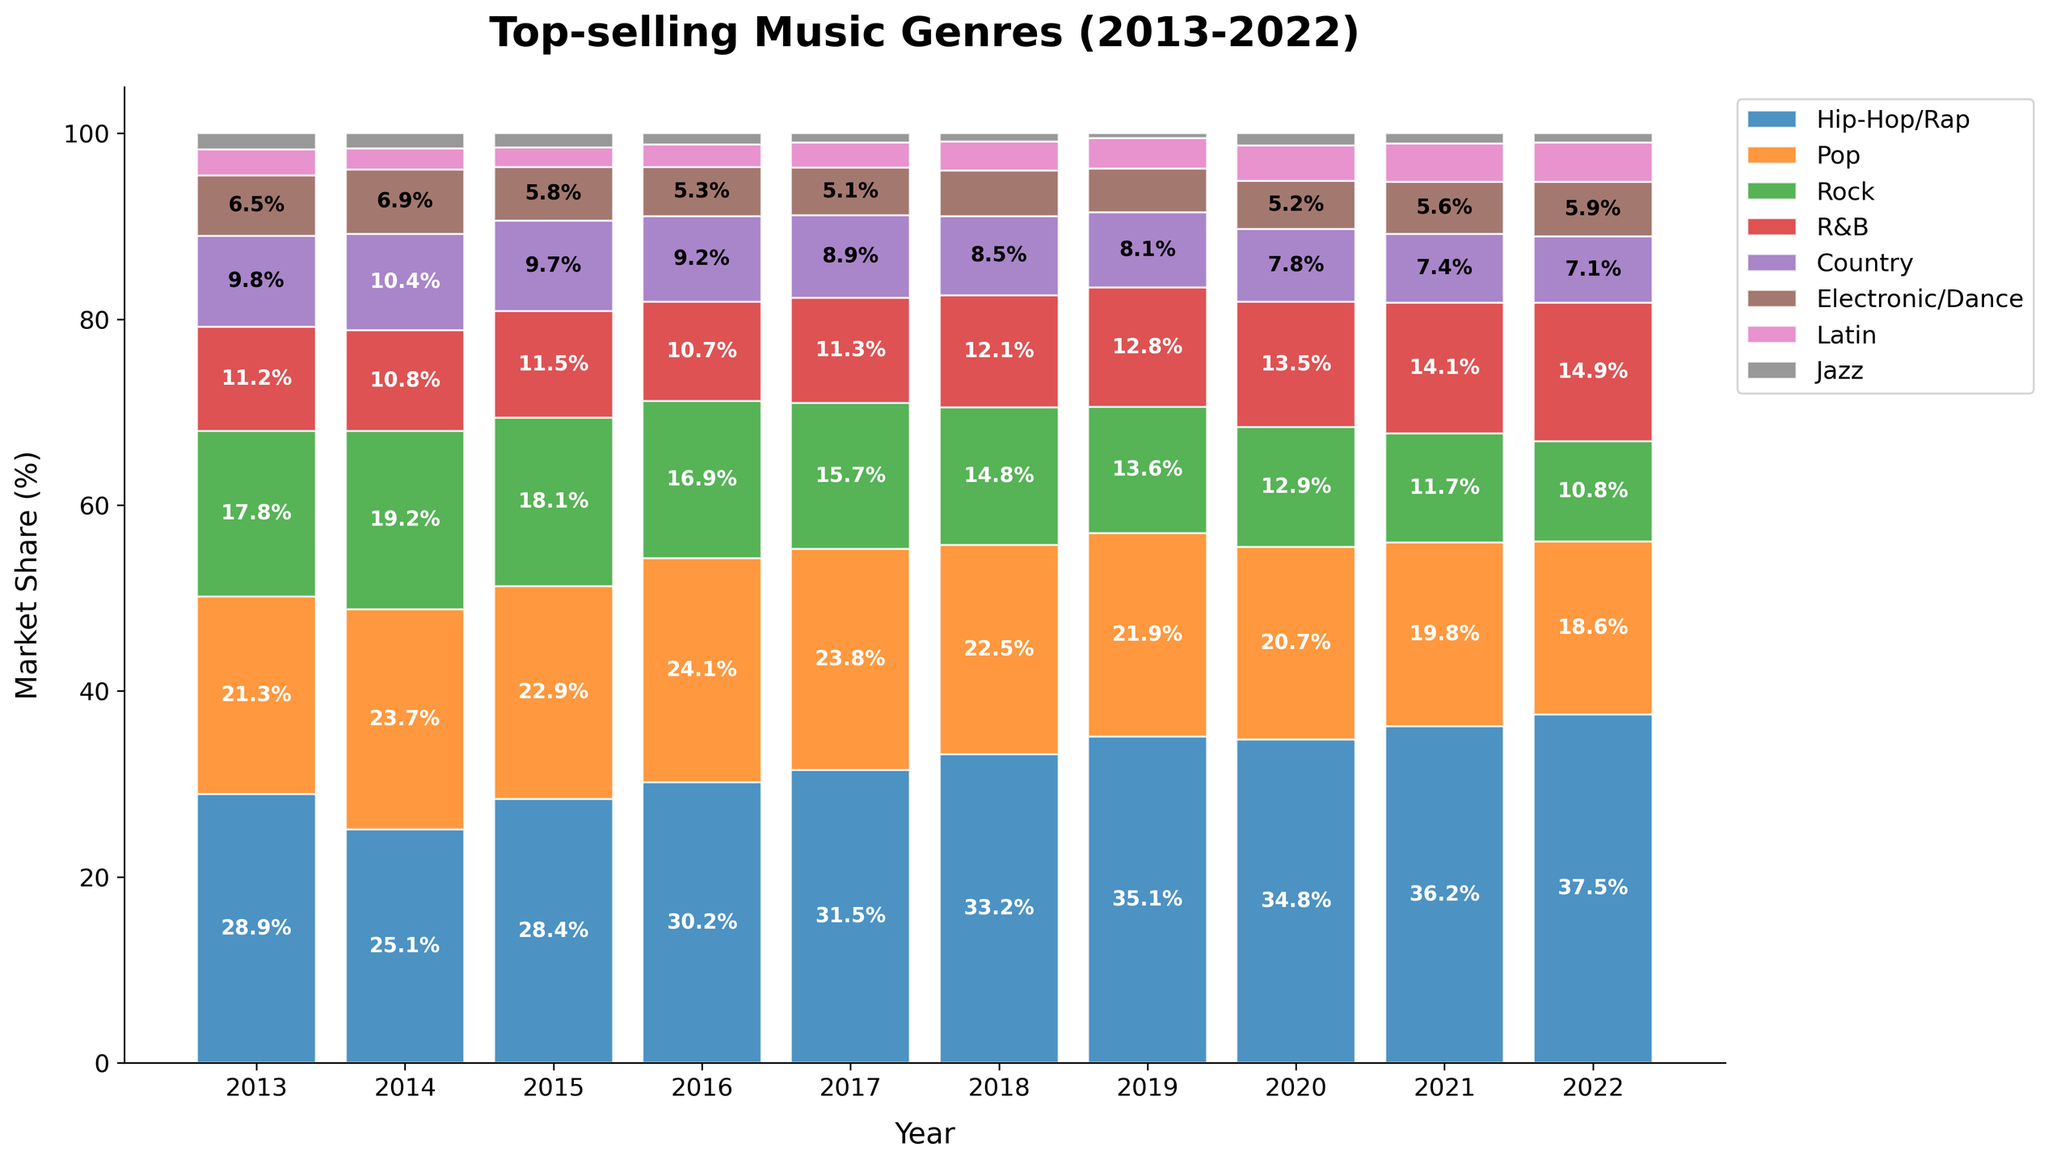How has the market share of Hip-Hop/Rap changed from 2013 to 2022? To find the change in market share of Hip-Hop/Rap from 2013 to 2022, subtract the market share in 2013 from the market share in 2022: 37.5 - 28.9 = 8.6.
Answer: 8.6% In which year did Pop music have the highest market share? To determine the year Pop music had the highest market share, look for the peak value in the Pop row of the data: the highest value is 24.1, which occurred in 2016.
Answer: 2016 Which genre had the greatest increase in market share over the decade? Calculate the increase in market share for each genre by subtracting their values in 2013 from their values in 2022, then identify the largest difference. Hip-Hop/Rap had the largest increase: 37.5 - 28.9 = 8.6.
Answer: Hip-Hop/Rap By how much did the market share of Rock decrease from 2013 to 2022? Subtract the market share of Rock in 2022 from its market share in 2013 to find the decrease: 17.8 - 10.8 = 7.0.
Answer: 7.0% In what year did R&B first exceed 13% market share? Scan the R&B row for the first year where the market share is greater than 13%. This happened in 2019 with a market share of 13.5%.
Answer: 2019 Compare the market share of Jazz in 2013 to its market share in 2022. Did it increase or decrease? Compare the Jazz market share values for 2013 and 2022. The share was 1.7% in 2013 and 1.0% in 2022, indicating a decrease.
Answer: Decrease Which genre consistently had the lowest market share during the decade? Identify the genre with the lowest values in each year and see if one genre repeatedly has the lowest market share. Jazz consistently had the lowest market share.
Answer: Jazz What’s the combined market share of Country and Electronic/Dance in 2022? Add the market shares of Country and Electronic/Dance for 2022: 7.1 + 5.9 = 13.0.
Answer: 13.0% Did the market share of Latin music ever surpass that of Electronic/Dance music? If so, in which years? Compare the market share values of Latin and Electronic/Dance for each year. Latin surpassed Electronic/Dance in 2018, 2019, 2020, 2021, and 2022.
Answer: 2018, 2019, 2020, 2021, 2022 Which genre's market share showed the most variability (largest range) over the decade? Calculate the range (difference between maximum and minimum percentage) for each genre. Hip-Hop/Rap has the largest range: 37.5 - 25.1 = 12.4.
Answer: Hip-Hop/Rap 